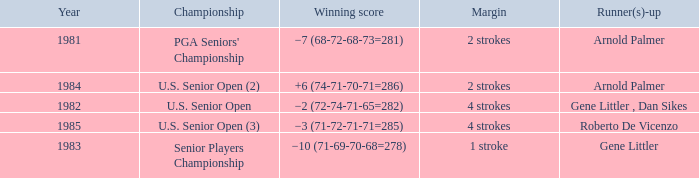What margin was in after 1981, and was Roberto De Vicenzo runner-up? 4 strokes. 